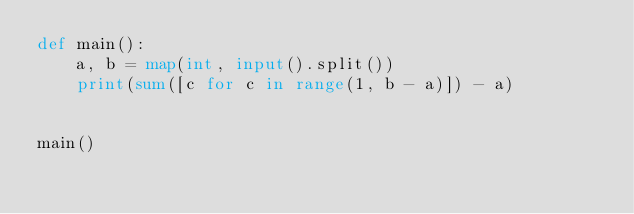Convert code to text. <code><loc_0><loc_0><loc_500><loc_500><_Python_>def main():
    a, b = map(int, input().split())
    print(sum([c for c in range(1, b - a)]) - a)


main()
</code> 